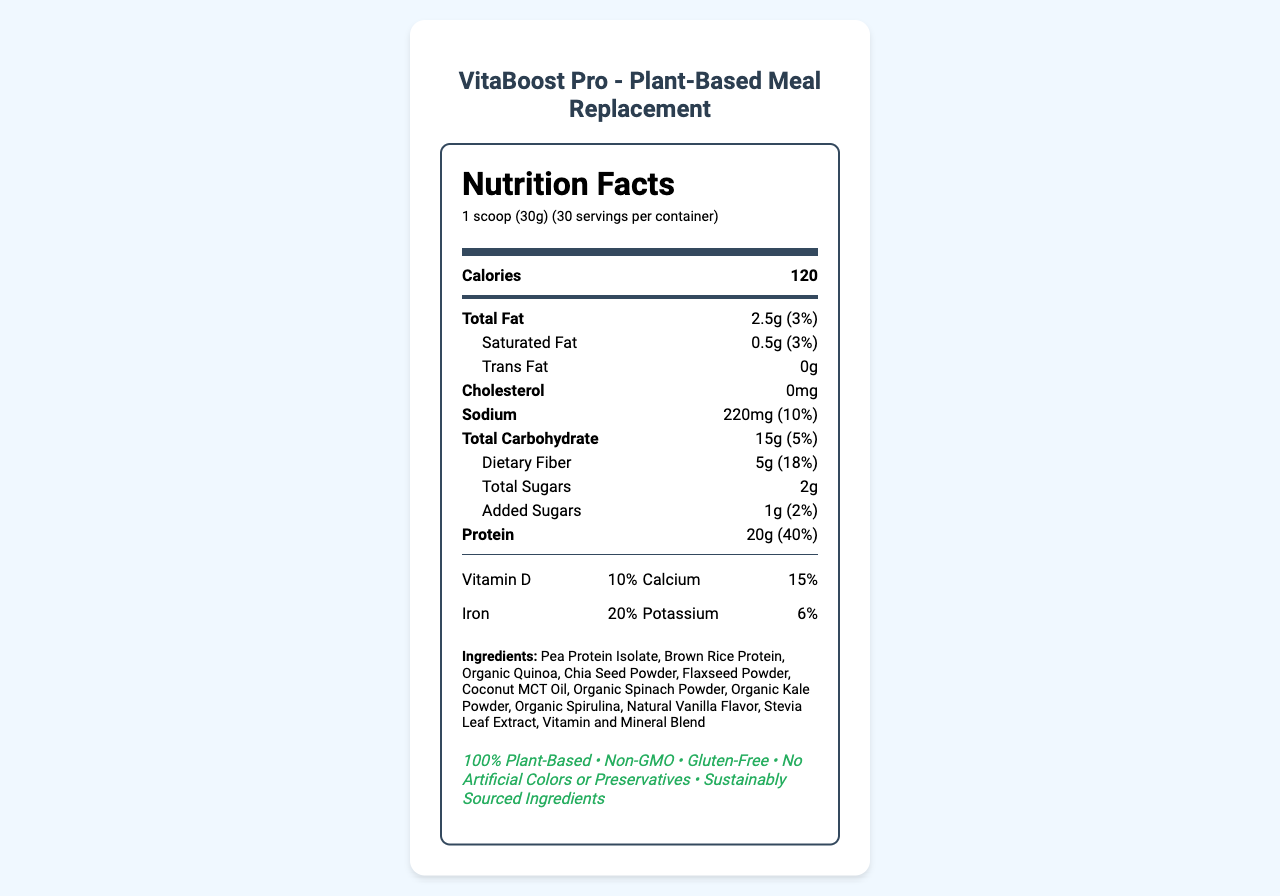what is the serving size? The serving size is indicated in the document as "1 scoop (30g)".
Answer: 1 scoop (30g) how many calories are in each serving? The nutrition label clearly states that each serving contains 120 calories.
Answer: 120 how much protein does one serving provide? According to the nutrition facts, each serving contains 20g of protein.
Answer: 20g what is the total carbohydrate percentage of the daily value per serving? The document lists the total carbohydrate daily value as 5%.
Answer: 5% what percentage of daily value of vitamin C is in one serving? The document states that one serving provides 35% of the daily value for vitamin C.
Answer: 35% which of the following is not an ingredient in VitaBoost Pro? A. Organic Quinoa B. Coconut Milk C. Chia Seed Powder D. Stevia Leaf Extract The ingredients list includes Organic Quinoa, Chia Seed Powder, and Stevia Leaf Extract, but not Coconut Milk.
Answer: B what type of facility is VitaBoost Pro manufactured in according to the allergen info? A. Dairy-processing B. Tree nuts and soy-processing C. Gluten-processing D. Fish-processing The allergen information states it is manufactured in a facility that also processes tree nuts and soy.
Answer: B is VitaBoost Pro gluten-free? The marketing claims include "Gluten-Free".
Answer: Yes what kind of packaging does VitaBoost Pro have? The document mentions that the packaging is recyclable and biodegradable and made from 100% post-consumer recycled materials.
Answer: Recyclable and biodegradable container made from 100% post-consumer recycled materials what is the price per container when subscribed monthly? The subscription model indicates that the price per container is $44.99 with monthly delivery.
Answer: $44.99 how much calcium is there in VitaBoost Pro per serving? The nutrition facts show that there is 200mg of calcium per serving.
Answer: 200mg what is the main idea of this document? The document details the nutritional information of VitaBoost Pro including its ingredients, allergen information, health claims, eco-friendly packaging, social impact, and pricing options.
Answer: The document provides the nutrition facts and details about VitaBoost Pro, a plant-based meal replacement shake aimed at health-conscious professionals. It highlights the nutritional content, ingredients, allergen information, marketing claims, packaging details, social impact, target audience, usage recommendations, and pricing including a subscription model. how much Vitamin A does each serving of VitaBoost Pro provide? The document does not explicitly state the amount of Vitamin A per serving, only the percentage of daily value.
Answer: Not enough information how much dietary fiber is in each serving in terms of daily value percentage? The document states that the dietary fiber in one serving is 18% of the daily value.
Answer: 18% 